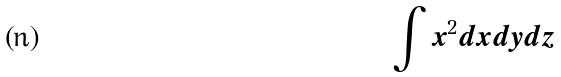<formula> <loc_0><loc_0><loc_500><loc_500>\int x ^ { 2 } d x d y d z</formula> 